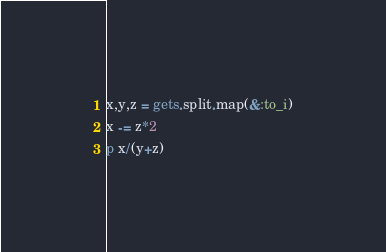Convert code to text. <code><loc_0><loc_0><loc_500><loc_500><_Ruby_>x,y,z = gets.split.map(&:to_i)
x -= z*2
p x/(y+z)
</code> 